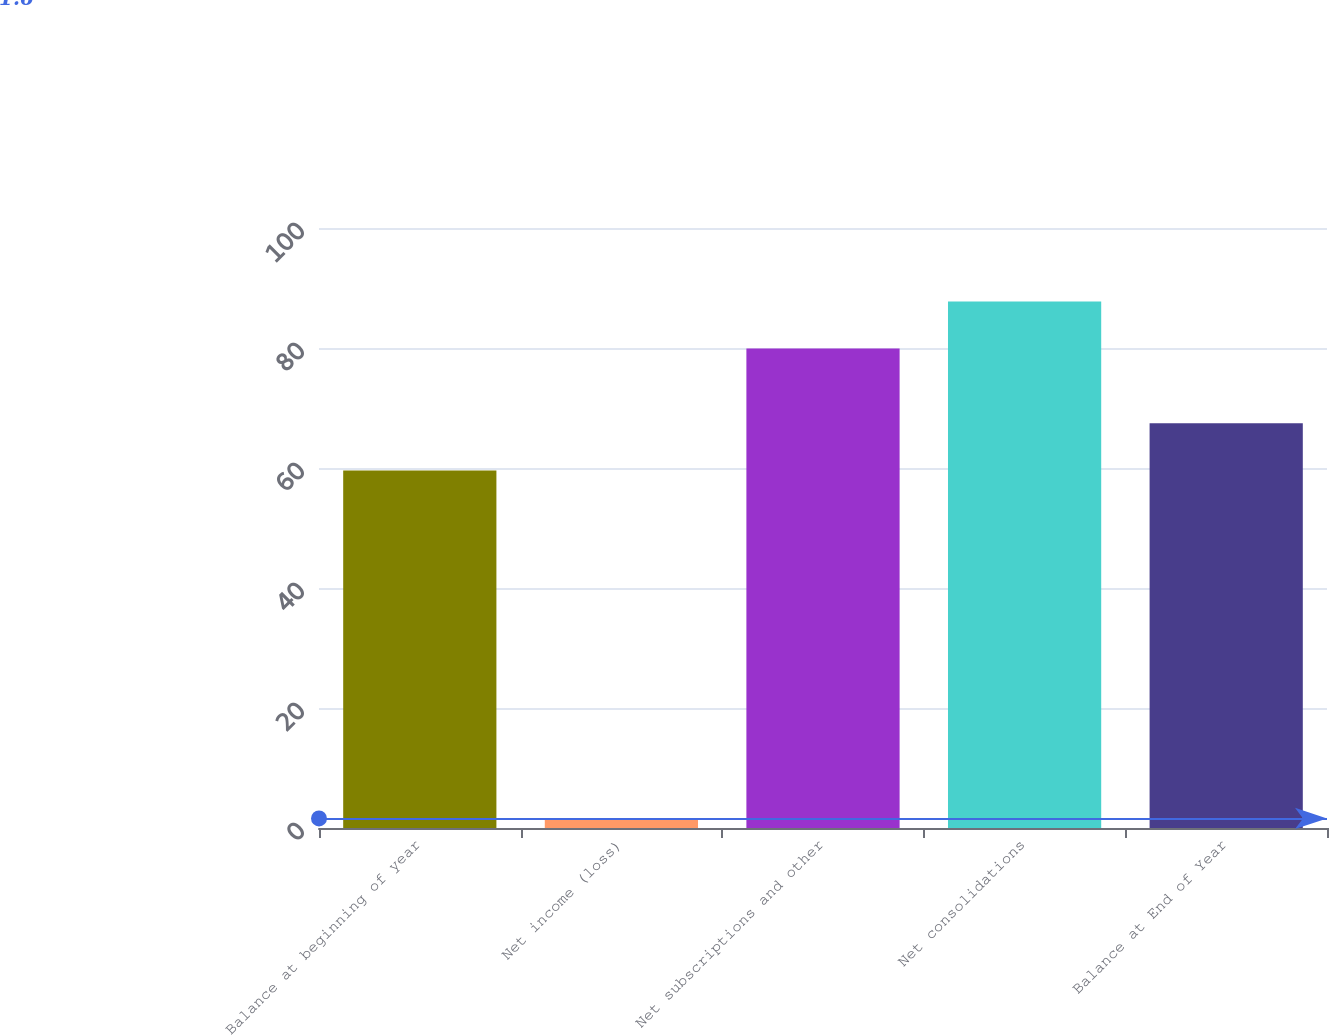Convert chart. <chart><loc_0><loc_0><loc_500><loc_500><bar_chart><fcel>Balance at beginning of year<fcel>Net income (loss)<fcel>Net subscriptions and other<fcel>Net consolidations<fcel>Balance at End of Year<nl><fcel>59.6<fcel>1.6<fcel>79.9<fcel>87.74<fcel>67.44<nl></chart> 